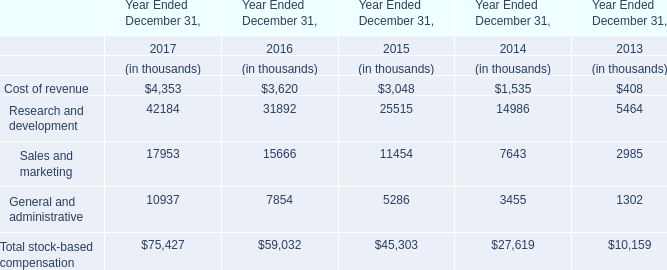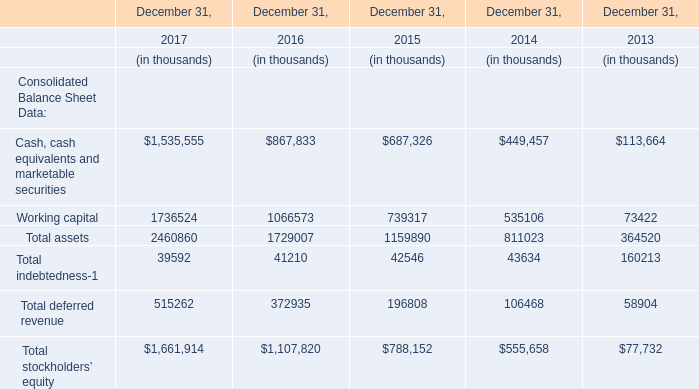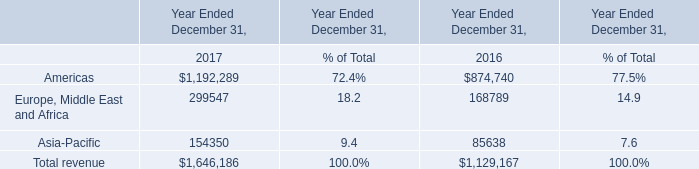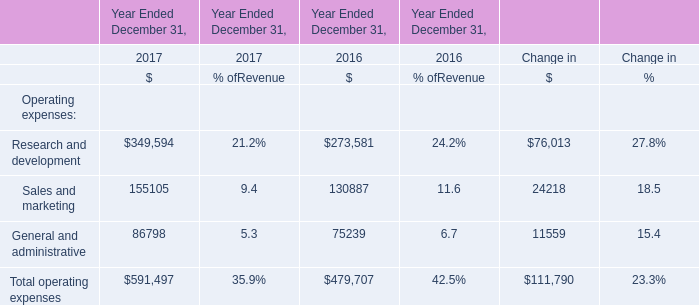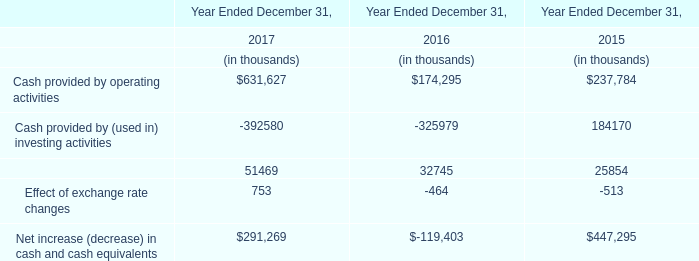What's the total amount of Cost of revenue, Research and development, Sales and marketing and General and administrative in 2017? (in thousands) 
Computations: (((4353 + 42184) + 17953) + 10937)
Answer: 75427.0. 